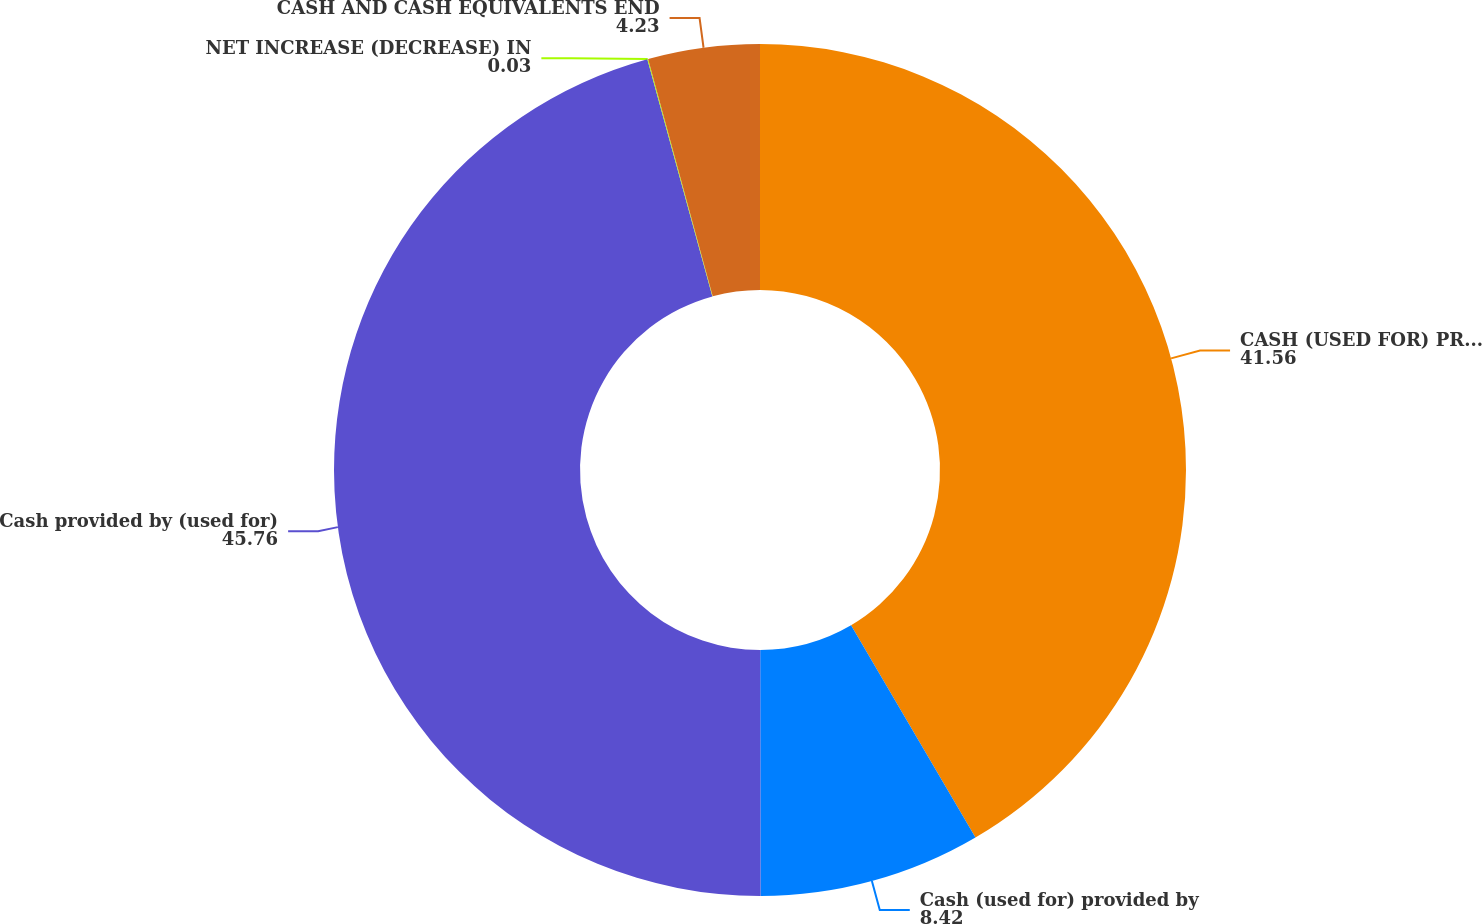Convert chart. <chart><loc_0><loc_0><loc_500><loc_500><pie_chart><fcel>CASH (USED FOR) PROVIDED BY<fcel>Cash (used for) provided by<fcel>Cash provided by (used for)<fcel>NET INCREASE (DECREASE) IN<fcel>CASH AND CASH EQUIVALENTS END<nl><fcel>41.56%<fcel>8.42%<fcel>45.76%<fcel>0.03%<fcel>4.23%<nl></chart> 